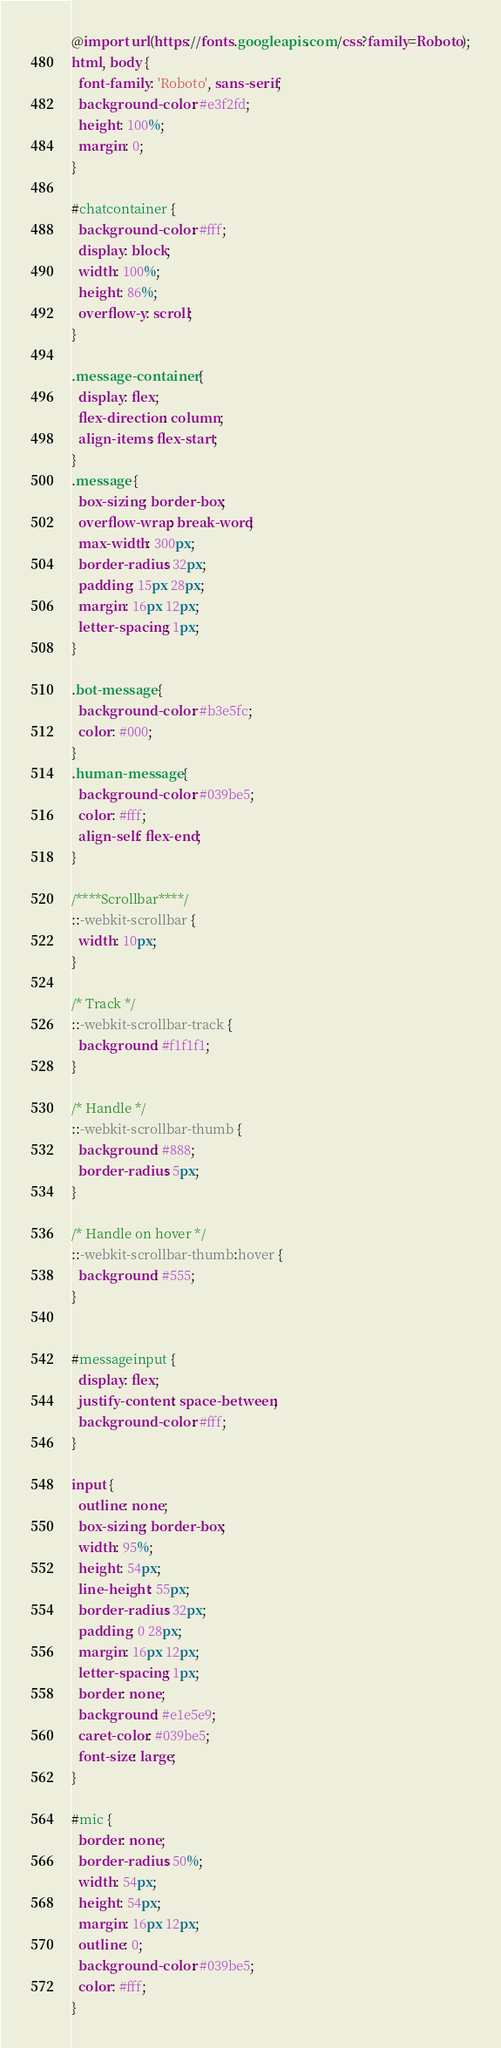Convert code to text. <code><loc_0><loc_0><loc_500><loc_500><_CSS_>@import url(https://fonts.googleapis.com/css?family=Roboto);
html, body {
  font-family: 'Roboto', sans-serif;
  background-color: #e3f2fd;
  height: 100%;
  margin: 0;
}

#chatcontainer {
  background-color: #fff;
  display: block;
  width: 100%;
  height: 86%;
  overflow-y: scroll;
}

.message-container {
  display: flex;
  flex-direction: column;
  align-items: flex-start;
}
.message {
  box-sizing: border-box;
  overflow-wrap: break-word;
  max-width: 300px;
  border-radius: 32px;
  padding: 15px 28px;
  margin: 16px 12px;
  letter-spacing: 1px;
}

.bot-message {
  background-color: #b3e5fc;
  color: #000;
}
.human-message {
  background-color: #039be5; 
  color: #fff;
  align-self: flex-end;
}

/****Scrollbar****/
::-webkit-scrollbar {
  width: 10px;
}

/* Track */
::-webkit-scrollbar-track {
  background: #f1f1f1; 
}
 
/* Handle */
::-webkit-scrollbar-thumb {
  background: #888; 
  border-radius: 5px;
}

/* Handle on hover */
::-webkit-scrollbar-thumb:hover {
  background: #555; 
}


#messageinput {
  display: flex;
  justify-content: space-between;
  background-color: #fff;
}

input {
  outline: none;
  box-sizing: border-box;
  width: 95%;
  height: 54px;
  line-height: 55px;
  border-radius: 32px;
  padding: 0 28px;
  margin: 16px 12px;
  letter-spacing: 1px;
  border: none;
  background: #e1e5e9;
  caret-color: #039be5;
  font-size: large;
}

#mic {
  border: none;
  border-radius: 50%;
  width: 54px;
  height: 54px;
  margin: 16px 12px;
  outline: 0;
  background-color: #039be5;
  color: #fff;
}
</code> 